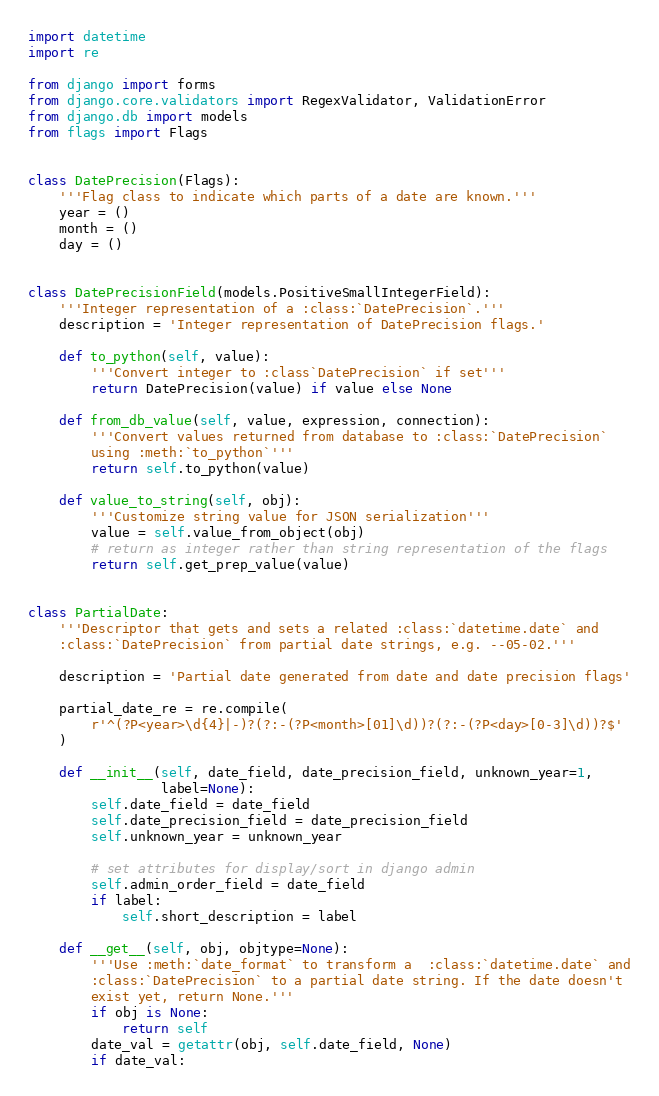Convert code to text. <code><loc_0><loc_0><loc_500><loc_500><_Python_>import datetime
import re

from django import forms
from django.core.validators import RegexValidator, ValidationError
from django.db import models
from flags import Flags


class DatePrecision(Flags):
    '''Flag class to indicate which parts of a date are known.'''
    year = ()
    month = ()
    day = ()


class DatePrecisionField(models.PositiveSmallIntegerField):
    '''Integer representation of a :class:`DatePrecision`.'''
    description = 'Integer representation of DatePrecision flags.'

    def to_python(self, value):
        '''Convert integer to :class`DatePrecision` if set'''
        return DatePrecision(value) if value else None

    def from_db_value(self, value, expression, connection):
        '''Convert values returned from database to :class:`DatePrecision`
        using :meth:`to_python`'''
        return self.to_python(value)

    def value_to_string(self, obj):
        '''Customize string value for JSON serialization'''
        value = self.value_from_object(obj)
        # return as integer rather than string representation of the flags
        return self.get_prep_value(value)


class PartialDate:
    '''Descriptor that gets and sets a related :class:`datetime.date` and
    :class:`DatePrecision` from partial date strings, e.g. --05-02.'''

    description = 'Partial date generated from date and date precision flags'

    partial_date_re = re.compile(
        r'^(?P<year>\d{4}|-)?(?:-(?P<month>[01]\d))?(?:-(?P<day>[0-3]\d))?$'
    )

    def __init__(self, date_field, date_precision_field, unknown_year=1,
                 label=None):
        self.date_field = date_field
        self.date_precision_field = date_precision_field
        self.unknown_year = unknown_year

        # set attributes for display/sort in django admin
        self.admin_order_field = date_field
        if label:
            self.short_description = label

    def __get__(self, obj, objtype=None):
        '''Use :meth:`date_format` to transform a  :class:`datetime.date` and
        :class:`DatePrecision` to a partial date string. If the date doesn't
        exist yet, return None.'''
        if obj is None:
            return self
        date_val = getattr(obj, self.date_field, None)
        if date_val:</code> 